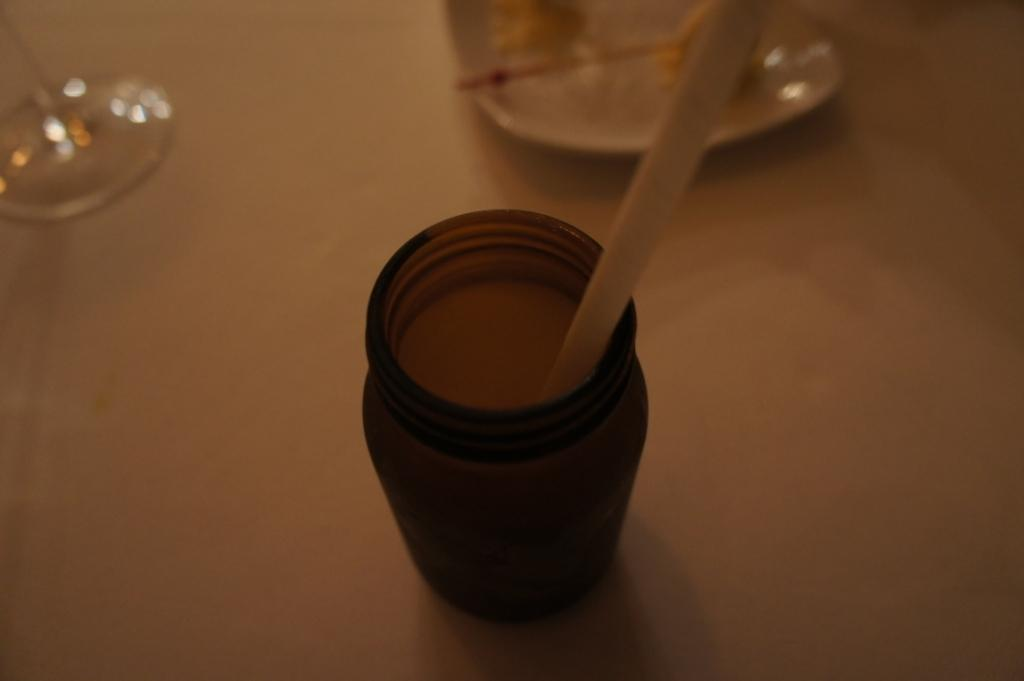What is the object on the table that is used for sweetening beverages? There is a sugar bottle in the image. What is the object on the table that is used for drinking? There is a glass in the image. Where are the sugar bottle and the glass located in the image? Both the sugar bottle and the glass are placed on a table. Can you see a wren perched on the sugar bottle in the image? There is no wren present in the image. 